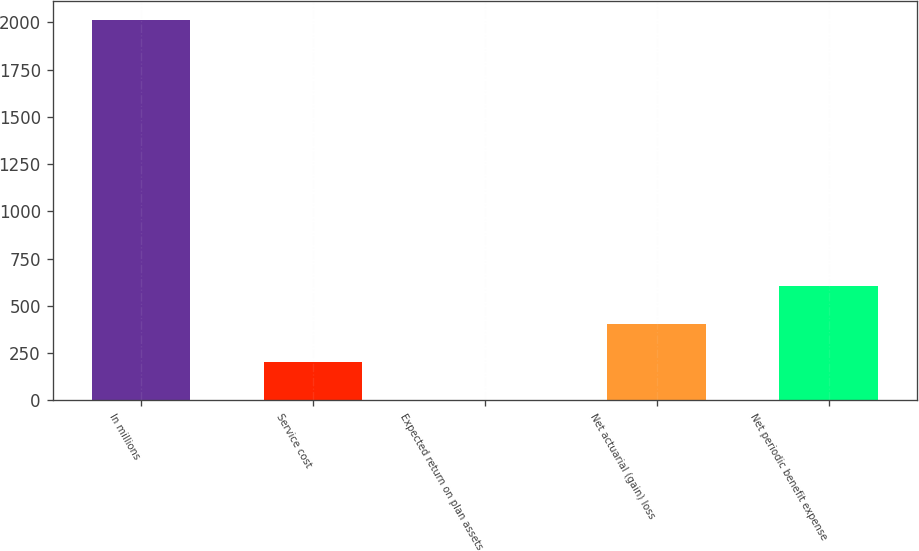Convert chart to OTSL. <chart><loc_0><loc_0><loc_500><loc_500><bar_chart><fcel>In millions<fcel>Service cost<fcel>Expected return on plan assets<fcel>Net actuarial (gain) loss<fcel>Net periodic benefit expense<nl><fcel>2014<fcel>202.93<fcel>1.7<fcel>404.16<fcel>605.39<nl></chart> 